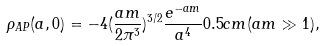Convert formula to latex. <formula><loc_0><loc_0><loc_500><loc_500>\rho _ { A P } ( a , 0 ) = - 4 ( \frac { a m } { 2 \pi ^ { 3 } } ) ^ { 3 / 2 } \frac { e ^ { - a m } } { a ^ { 4 } } 0 . 5 c m ( a m \gg 1 ) ,</formula> 